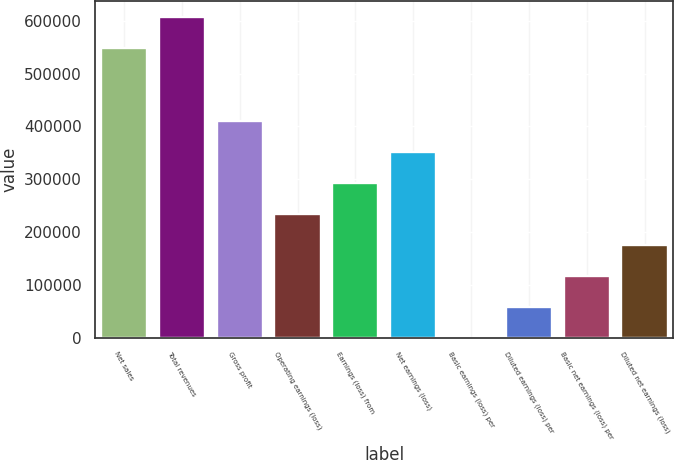Convert chart. <chart><loc_0><loc_0><loc_500><loc_500><bar_chart><fcel>Net sales<fcel>Total revenues<fcel>Gross profit<fcel>Operating earnings (loss)<fcel>Earnings (loss) from<fcel>Net earnings (loss)<fcel>Basic earnings (loss) per<fcel>Diluted earnings (loss) per<fcel>Basic net earnings (loss) per<fcel>Diluted net earnings (loss)<nl><fcel>548832<fcel>607456<fcel>410369<fcel>234497<fcel>293121<fcel>351745<fcel>0.36<fcel>58624.5<fcel>117249<fcel>175873<nl></chart> 